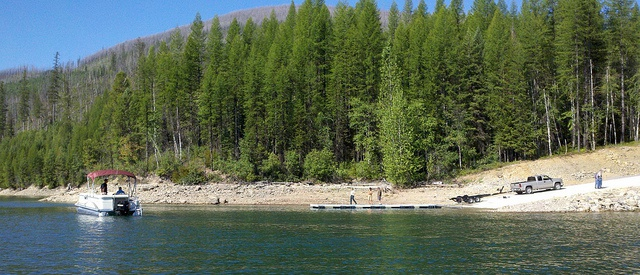Describe the objects in this image and their specific colors. I can see boat in lightblue, white, black, gray, and darkgray tones, truck in lightblue, darkgray, lightgray, gray, and black tones, people in lightblue, tan, and beige tones, people in lightblue, black, gray, darkgray, and lightgray tones, and people in lightblue, gray, darkgray, and lightgray tones in this image. 